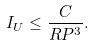<formula> <loc_0><loc_0><loc_500><loc_500>I _ { U } \leq \frac { C } { R P ^ { 3 } } .</formula> 